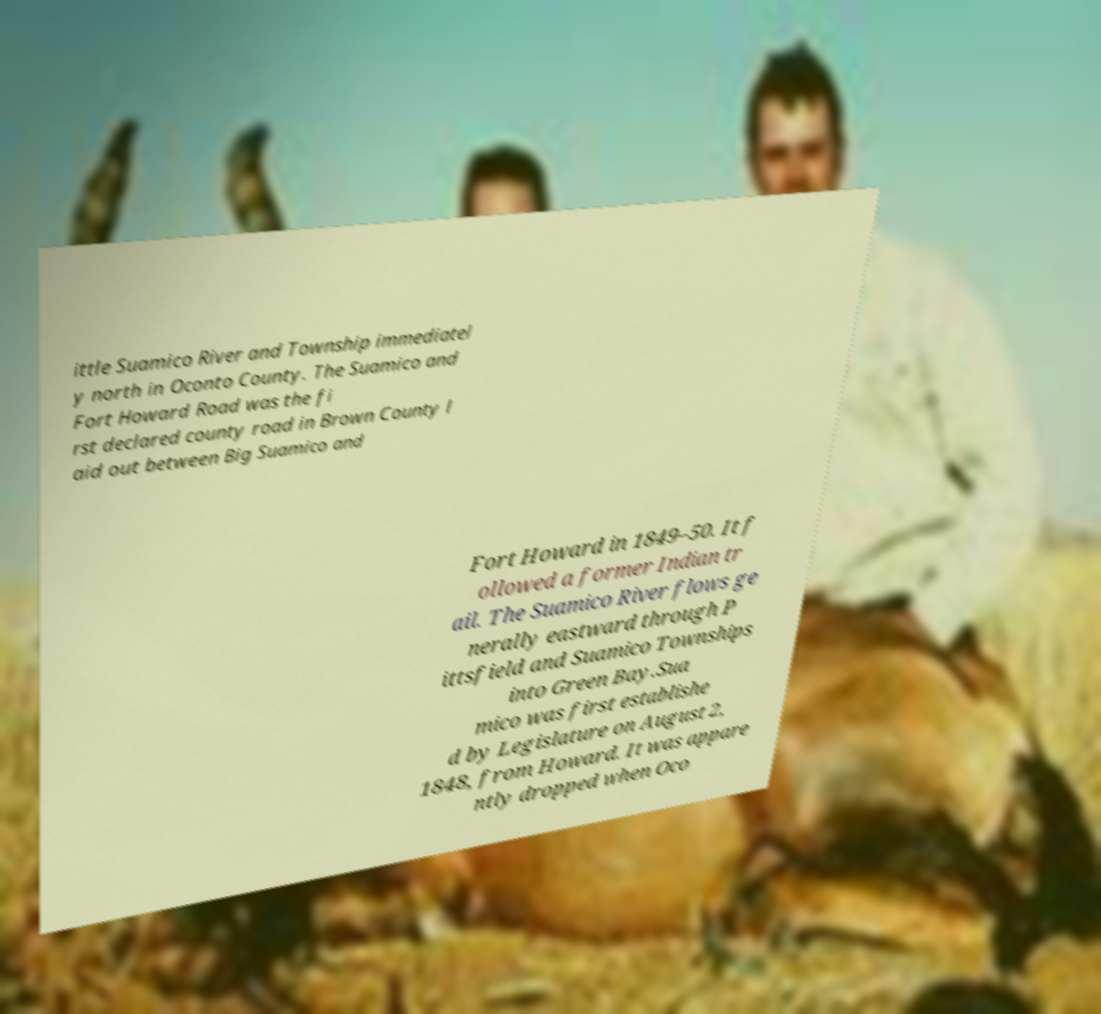What messages or text are displayed in this image? I need them in a readable, typed format. ittle Suamico River and Township immediatel y north in Oconto County. The Suamico and Fort Howard Road was the fi rst declared county road in Brown County l aid out between Big Suamico and Fort Howard in 1849–50. It f ollowed a former Indian tr ail. The Suamico River flows ge nerally eastward through P ittsfield and Suamico Townships into Green Bay.Sua mico was first establishe d by Legislature on August 2, 1848, from Howard. It was appare ntly dropped when Oco 